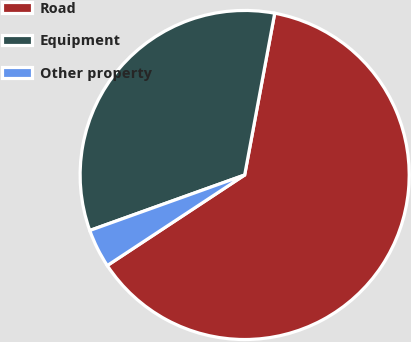<chart> <loc_0><loc_0><loc_500><loc_500><pie_chart><fcel>Road<fcel>Equipment<fcel>Other property<nl><fcel>62.8%<fcel>33.4%<fcel>3.8%<nl></chart> 